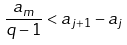<formula> <loc_0><loc_0><loc_500><loc_500>\frac { a _ { m } } { q - 1 } < a _ { j + 1 } - a _ { j }</formula> 